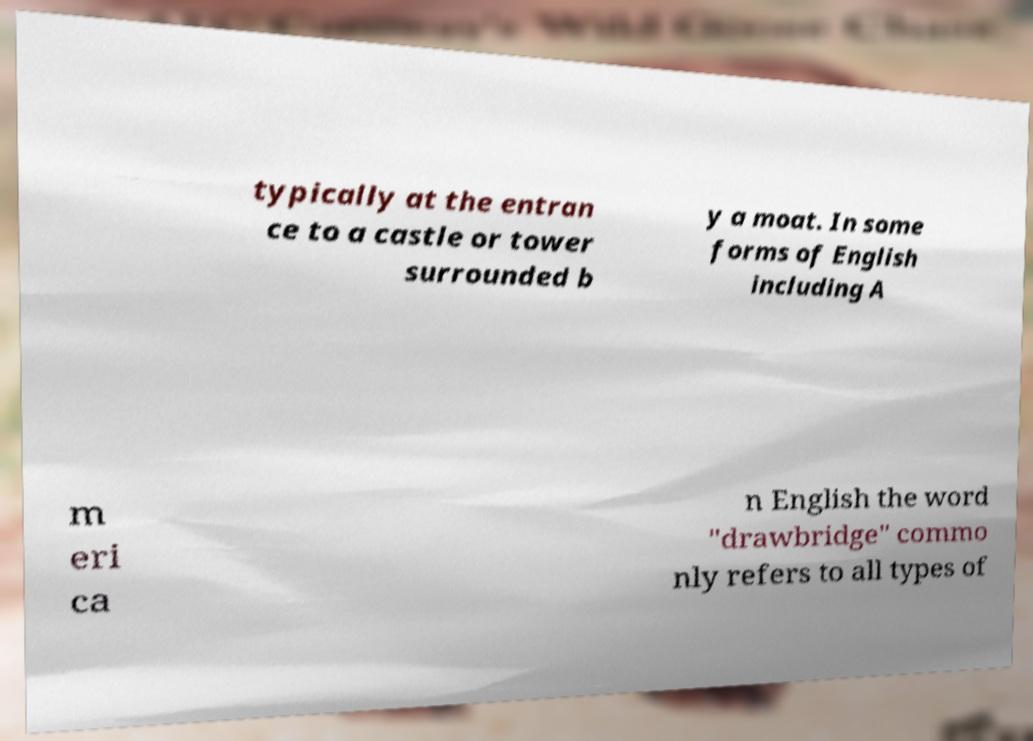Could you extract and type out the text from this image? typically at the entran ce to a castle or tower surrounded b y a moat. In some forms of English including A m eri ca n English the word "drawbridge" commo nly refers to all types of 